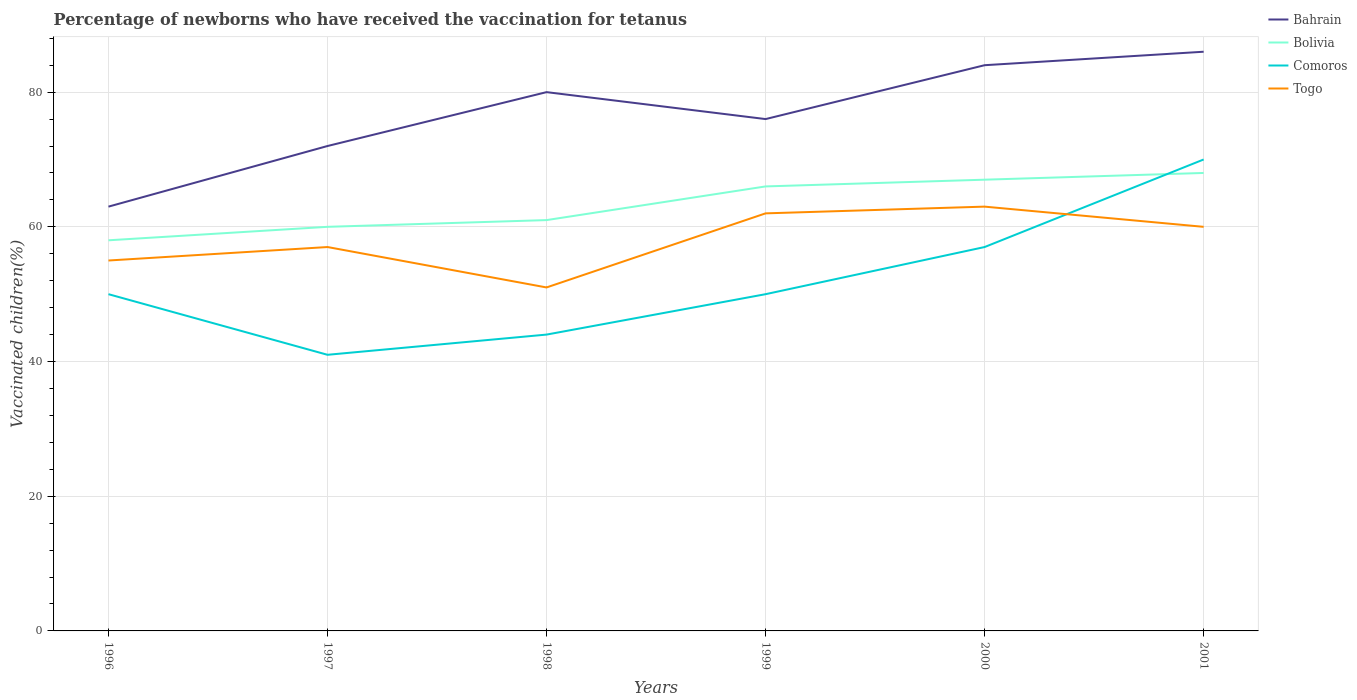How many different coloured lines are there?
Offer a terse response. 4. Does the line corresponding to Togo intersect with the line corresponding to Bahrain?
Your answer should be compact. No. Is the number of lines equal to the number of legend labels?
Give a very brief answer. Yes. Across all years, what is the maximum percentage of vaccinated children in Bolivia?
Provide a succinct answer. 58. What is the total percentage of vaccinated children in Bolivia in the graph?
Offer a terse response. -8. Is the percentage of vaccinated children in Togo strictly greater than the percentage of vaccinated children in Bahrain over the years?
Make the answer very short. Yes. What is the difference between two consecutive major ticks on the Y-axis?
Your answer should be very brief. 20. Are the values on the major ticks of Y-axis written in scientific E-notation?
Ensure brevity in your answer.  No. Does the graph contain any zero values?
Make the answer very short. No. Where does the legend appear in the graph?
Your answer should be very brief. Top right. How are the legend labels stacked?
Provide a succinct answer. Vertical. What is the title of the graph?
Offer a terse response. Percentage of newborns who have received the vaccination for tetanus. What is the label or title of the Y-axis?
Your response must be concise. Vaccinated children(%). What is the Vaccinated children(%) of Bahrain in 1996?
Make the answer very short. 63. What is the Vaccinated children(%) of Bolivia in 1996?
Your response must be concise. 58. What is the Vaccinated children(%) in Comoros in 1996?
Your answer should be compact. 50. What is the Vaccinated children(%) of Togo in 1996?
Keep it short and to the point. 55. What is the Vaccinated children(%) of Bolivia in 1997?
Provide a short and direct response. 60. What is the Vaccinated children(%) in Comoros in 1997?
Ensure brevity in your answer.  41. What is the Vaccinated children(%) in Togo in 1997?
Your answer should be very brief. 57. What is the Vaccinated children(%) in Comoros in 1998?
Your answer should be very brief. 44. What is the Vaccinated children(%) of Togo in 1998?
Offer a terse response. 51. What is the Vaccinated children(%) of Bahrain in 1999?
Give a very brief answer. 76. What is the Vaccinated children(%) in Bolivia in 1999?
Provide a succinct answer. 66. What is the Vaccinated children(%) of Bolivia in 2000?
Ensure brevity in your answer.  67. What is the Vaccinated children(%) of Comoros in 2000?
Give a very brief answer. 57. What is the Vaccinated children(%) of Togo in 2000?
Make the answer very short. 63. What is the Vaccinated children(%) of Bahrain in 2001?
Ensure brevity in your answer.  86. What is the Vaccinated children(%) of Bolivia in 2001?
Provide a succinct answer. 68. What is the Vaccinated children(%) in Comoros in 2001?
Provide a succinct answer. 70. What is the Vaccinated children(%) of Togo in 2001?
Offer a very short reply. 60. Across all years, what is the maximum Vaccinated children(%) of Bolivia?
Provide a succinct answer. 68. Across all years, what is the maximum Vaccinated children(%) in Comoros?
Give a very brief answer. 70. Across all years, what is the maximum Vaccinated children(%) in Togo?
Provide a short and direct response. 63. Across all years, what is the minimum Vaccinated children(%) in Bolivia?
Offer a very short reply. 58. Across all years, what is the minimum Vaccinated children(%) of Comoros?
Ensure brevity in your answer.  41. What is the total Vaccinated children(%) in Bahrain in the graph?
Offer a terse response. 461. What is the total Vaccinated children(%) of Bolivia in the graph?
Your answer should be compact. 380. What is the total Vaccinated children(%) in Comoros in the graph?
Your answer should be very brief. 312. What is the total Vaccinated children(%) in Togo in the graph?
Provide a short and direct response. 348. What is the difference between the Vaccinated children(%) of Bahrain in 1996 and that in 1997?
Your answer should be compact. -9. What is the difference between the Vaccinated children(%) in Bahrain in 1996 and that in 1998?
Offer a terse response. -17. What is the difference between the Vaccinated children(%) of Togo in 1996 and that in 1998?
Your answer should be compact. 4. What is the difference between the Vaccinated children(%) in Comoros in 1996 and that in 1999?
Give a very brief answer. 0. What is the difference between the Vaccinated children(%) of Bahrain in 1996 and that in 2000?
Your answer should be very brief. -21. What is the difference between the Vaccinated children(%) of Bolivia in 1996 and that in 2000?
Give a very brief answer. -9. What is the difference between the Vaccinated children(%) of Comoros in 1996 and that in 2000?
Provide a succinct answer. -7. What is the difference between the Vaccinated children(%) in Bahrain in 1996 and that in 2001?
Offer a very short reply. -23. What is the difference between the Vaccinated children(%) in Bolivia in 1996 and that in 2001?
Offer a terse response. -10. What is the difference between the Vaccinated children(%) of Comoros in 1996 and that in 2001?
Provide a short and direct response. -20. What is the difference between the Vaccinated children(%) of Togo in 1996 and that in 2001?
Make the answer very short. -5. What is the difference between the Vaccinated children(%) in Bolivia in 1997 and that in 1998?
Provide a short and direct response. -1. What is the difference between the Vaccinated children(%) in Comoros in 1997 and that in 1998?
Offer a terse response. -3. What is the difference between the Vaccinated children(%) of Bahrain in 1997 and that in 1999?
Your answer should be very brief. -4. What is the difference between the Vaccinated children(%) in Togo in 1997 and that in 1999?
Provide a short and direct response. -5. What is the difference between the Vaccinated children(%) in Bahrain in 1997 and that in 2000?
Your answer should be very brief. -12. What is the difference between the Vaccinated children(%) of Bolivia in 1997 and that in 2000?
Offer a terse response. -7. What is the difference between the Vaccinated children(%) of Togo in 1997 and that in 2000?
Give a very brief answer. -6. What is the difference between the Vaccinated children(%) in Bolivia in 1997 and that in 2001?
Offer a terse response. -8. What is the difference between the Vaccinated children(%) in Bolivia in 1998 and that in 1999?
Make the answer very short. -5. What is the difference between the Vaccinated children(%) in Bahrain in 1998 and that in 2001?
Ensure brevity in your answer.  -6. What is the difference between the Vaccinated children(%) in Bolivia in 1998 and that in 2001?
Provide a short and direct response. -7. What is the difference between the Vaccinated children(%) in Bahrain in 1999 and that in 2000?
Provide a short and direct response. -8. What is the difference between the Vaccinated children(%) of Bolivia in 1999 and that in 2000?
Give a very brief answer. -1. What is the difference between the Vaccinated children(%) in Togo in 1999 and that in 2000?
Provide a succinct answer. -1. What is the difference between the Vaccinated children(%) of Bahrain in 1999 and that in 2001?
Keep it short and to the point. -10. What is the difference between the Vaccinated children(%) in Bolivia in 1999 and that in 2001?
Offer a very short reply. -2. What is the difference between the Vaccinated children(%) of Togo in 1999 and that in 2001?
Provide a succinct answer. 2. What is the difference between the Vaccinated children(%) of Bolivia in 2000 and that in 2001?
Provide a short and direct response. -1. What is the difference between the Vaccinated children(%) in Bahrain in 1996 and the Vaccinated children(%) in Bolivia in 1997?
Give a very brief answer. 3. What is the difference between the Vaccinated children(%) of Bahrain in 1996 and the Vaccinated children(%) of Comoros in 1997?
Your answer should be very brief. 22. What is the difference between the Vaccinated children(%) in Bahrain in 1996 and the Vaccinated children(%) in Togo in 1997?
Give a very brief answer. 6. What is the difference between the Vaccinated children(%) in Bolivia in 1996 and the Vaccinated children(%) in Comoros in 1997?
Offer a very short reply. 17. What is the difference between the Vaccinated children(%) in Bolivia in 1996 and the Vaccinated children(%) in Togo in 1997?
Your answer should be very brief. 1. What is the difference between the Vaccinated children(%) in Comoros in 1996 and the Vaccinated children(%) in Togo in 1997?
Your response must be concise. -7. What is the difference between the Vaccinated children(%) of Bahrain in 1996 and the Vaccinated children(%) of Bolivia in 1998?
Provide a short and direct response. 2. What is the difference between the Vaccinated children(%) in Bahrain in 1996 and the Vaccinated children(%) in Comoros in 1998?
Provide a succinct answer. 19. What is the difference between the Vaccinated children(%) in Comoros in 1996 and the Vaccinated children(%) in Togo in 1998?
Make the answer very short. -1. What is the difference between the Vaccinated children(%) in Bahrain in 1996 and the Vaccinated children(%) in Bolivia in 1999?
Your answer should be compact. -3. What is the difference between the Vaccinated children(%) in Bahrain in 1996 and the Vaccinated children(%) in Comoros in 1999?
Your answer should be compact. 13. What is the difference between the Vaccinated children(%) in Bolivia in 1996 and the Vaccinated children(%) in Comoros in 1999?
Make the answer very short. 8. What is the difference between the Vaccinated children(%) in Bolivia in 1996 and the Vaccinated children(%) in Togo in 1999?
Make the answer very short. -4. What is the difference between the Vaccinated children(%) of Bahrain in 1996 and the Vaccinated children(%) of Bolivia in 2000?
Keep it short and to the point. -4. What is the difference between the Vaccinated children(%) in Bahrain in 1996 and the Vaccinated children(%) in Togo in 2000?
Ensure brevity in your answer.  0. What is the difference between the Vaccinated children(%) of Bolivia in 1996 and the Vaccinated children(%) of Comoros in 2000?
Your response must be concise. 1. What is the difference between the Vaccinated children(%) of Bolivia in 1996 and the Vaccinated children(%) of Togo in 2000?
Your response must be concise. -5. What is the difference between the Vaccinated children(%) in Comoros in 1996 and the Vaccinated children(%) in Togo in 2000?
Provide a short and direct response. -13. What is the difference between the Vaccinated children(%) of Bahrain in 1996 and the Vaccinated children(%) of Bolivia in 2001?
Your answer should be compact. -5. What is the difference between the Vaccinated children(%) in Bolivia in 1996 and the Vaccinated children(%) in Comoros in 2001?
Keep it short and to the point. -12. What is the difference between the Vaccinated children(%) of Comoros in 1996 and the Vaccinated children(%) of Togo in 2001?
Your answer should be very brief. -10. What is the difference between the Vaccinated children(%) of Bahrain in 1997 and the Vaccinated children(%) of Bolivia in 1998?
Make the answer very short. 11. What is the difference between the Vaccinated children(%) in Bolivia in 1997 and the Vaccinated children(%) in Togo in 1998?
Ensure brevity in your answer.  9. What is the difference between the Vaccinated children(%) in Bahrain in 1997 and the Vaccinated children(%) in Togo in 1999?
Offer a very short reply. 10. What is the difference between the Vaccinated children(%) in Bolivia in 1997 and the Vaccinated children(%) in Comoros in 1999?
Provide a succinct answer. 10. What is the difference between the Vaccinated children(%) of Bolivia in 1997 and the Vaccinated children(%) of Togo in 1999?
Provide a succinct answer. -2. What is the difference between the Vaccinated children(%) of Bahrain in 1997 and the Vaccinated children(%) of Comoros in 2000?
Your answer should be compact. 15. What is the difference between the Vaccinated children(%) in Bolivia in 1997 and the Vaccinated children(%) in Comoros in 2000?
Keep it short and to the point. 3. What is the difference between the Vaccinated children(%) in Bahrain in 1997 and the Vaccinated children(%) in Bolivia in 2001?
Your response must be concise. 4. What is the difference between the Vaccinated children(%) of Bahrain in 1997 and the Vaccinated children(%) of Togo in 2001?
Make the answer very short. 12. What is the difference between the Vaccinated children(%) of Bolivia in 1997 and the Vaccinated children(%) of Comoros in 2001?
Ensure brevity in your answer.  -10. What is the difference between the Vaccinated children(%) in Comoros in 1997 and the Vaccinated children(%) in Togo in 2001?
Offer a very short reply. -19. What is the difference between the Vaccinated children(%) in Bahrain in 1998 and the Vaccinated children(%) in Comoros in 1999?
Keep it short and to the point. 30. What is the difference between the Vaccinated children(%) of Bolivia in 1998 and the Vaccinated children(%) of Comoros in 1999?
Offer a very short reply. 11. What is the difference between the Vaccinated children(%) of Bolivia in 1998 and the Vaccinated children(%) of Togo in 1999?
Your answer should be very brief. -1. What is the difference between the Vaccinated children(%) of Bahrain in 1998 and the Vaccinated children(%) of Bolivia in 2000?
Keep it short and to the point. 13. What is the difference between the Vaccinated children(%) in Bahrain in 1998 and the Vaccinated children(%) in Comoros in 2000?
Your answer should be compact. 23. What is the difference between the Vaccinated children(%) in Bahrain in 1998 and the Vaccinated children(%) in Togo in 2000?
Make the answer very short. 17. What is the difference between the Vaccinated children(%) in Bahrain in 1998 and the Vaccinated children(%) in Comoros in 2001?
Make the answer very short. 10. What is the difference between the Vaccinated children(%) in Bahrain in 1998 and the Vaccinated children(%) in Togo in 2001?
Provide a short and direct response. 20. What is the difference between the Vaccinated children(%) of Bolivia in 1998 and the Vaccinated children(%) of Togo in 2001?
Keep it short and to the point. 1. What is the difference between the Vaccinated children(%) of Comoros in 1998 and the Vaccinated children(%) of Togo in 2001?
Give a very brief answer. -16. What is the difference between the Vaccinated children(%) in Bahrain in 1999 and the Vaccinated children(%) in Bolivia in 2000?
Your answer should be very brief. 9. What is the difference between the Vaccinated children(%) of Bahrain in 1999 and the Vaccinated children(%) of Togo in 2000?
Keep it short and to the point. 13. What is the difference between the Vaccinated children(%) in Comoros in 1999 and the Vaccinated children(%) in Togo in 2000?
Keep it short and to the point. -13. What is the difference between the Vaccinated children(%) of Bahrain in 1999 and the Vaccinated children(%) of Bolivia in 2001?
Your response must be concise. 8. What is the difference between the Vaccinated children(%) of Bahrain in 1999 and the Vaccinated children(%) of Togo in 2001?
Offer a terse response. 16. What is the difference between the Vaccinated children(%) of Comoros in 1999 and the Vaccinated children(%) of Togo in 2001?
Provide a succinct answer. -10. What is the difference between the Vaccinated children(%) in Bahrain in 2000 and the Vaccinated children(%) in Bolivia in 2001?
Provide a succinct answer. 16. What is the difference between the Vaccinated children(%) in Bolivia in 2000 and the Vaccinated children(%) in Togo in 2001?
Your response must be concise. 7. What is the difference between the Vaccinated children(%) of Comoros in 2000 and the Vaccinated children(%) of Togo in 2001?
Give a very brief answer. -3. What is the average Vaccinated children(%) of Bahrain per year?
Give a very brief answer. 76.83. What is the average Vaccinated children(%) of Bolivia per year?
Offer a very short reply. 63.33. What is the average Vaccinated children(%) in Comoros per year?
Provide a short and direct response. 52. What is the average Vaccinated children(%) of Togo per year?
Your answer should be compact. 58. In the year 1996, what is the difference between the Vaccinated children(%) in Bahrain and Vaccinated children(%) in Bolivia?
Your answer should be very brief. 5. In the year 1996, what is the difference between the Vaccinated children(%) in Bolivia and Vaccinated children(%) in Comoros?
Offer a terse response. 8. In the year 1996, what is the difference between the Vaccinated children(%) of Comoros and Vaccinated children(%) of Togo?
Offer a very short reply. -5. In the year 1997, what is the difference between the Vaccinated children(%) of Bahrain and Vaccinated children(%) of Bolivia?
Give a very brief answer. 12. In the year 1997, what is the difference between the Vaccinated children(%) of Bahrain and Vaccinated children(%) of Comoros?
Offer a very short reply. 31. In the year 1997, what is the difference between the Vaccinated children(%) in Bahrain and Vaccinated children(%) in Togo?
Provide a short and direct response. 15. In the year 1997, what is the difference between the Vaccinated children(%) of Bolivia and Vaccinated children(%) of Comoros?
Provide a short and direct response. 19. In the year 1997, what is the difference between the Vaccinated children(%) in Bolivia and Vaccinated children(%) in Togo?
Provide a short and direct response. 3. In the year 1997, what is the difference between the Vaccinated children(%) in Comoros and Vaccinated children(%) in Togo?
Offer a very short reply. -16. In the year 1998, what is the difference between the Vaccinated children(%) of Bahrain and Vaccinated children(%) of Bolivia?
Your answer should be very brief. 19. In the year 1998, what is the difference between the Vaccinated children(%) in Bahrain and Vaccinated children(%) in Comoros?
Your response must be concise. 36. In the year 1998, what is the difference between the Vaccinated children(%) of Bolivia and Vaccinated children(%) of Togo?
Give a very brief answer. 10. In the year 1999, what is the difference between the Vaccinated children(%) in Bahrain and Vaccinated children(%) in Bolivia?
Offer a terse response. 10. In the year 1999, what is the difference between the Vaccinated children(%) of Comoros and Vaccinated children(%) of Togo?
Your answer should be very brief. -12. In the year 2000, what is the difference between the Vaccinated children(%) in Bolivia and Vaccinated children(%) in Togo?
Give a very brief answer. 4. In the year 2001, what is the difference between the Vaccinated children(%) of Bahrain and Vaccinated children(%) of Togo?
Your response must be concise. 26. In the year 2001, what is the difference between the Vaccinated children(%) in Bolivia and Vaccinated children(%) in Comoros?
Ensure brevity in your answer.  -2. In the year 2001, what is the difference between the Vaccinated children(%) in Comoros and Vaccinated children(%) in Togo?
Keep it short and to the point. 10. What is the ratio of the Vaccinated children(%) of Bahrain in 1996 to that in 1997?
Make the answer very short. 0.88. What is the ratio of the Vaccinated children(%) of Bolivia in 1996 to that in 1997?
Make the answer very short. 0.97. What is the ratio of the Vaccinated children(%) of Comoros in 1996 to that in 1997?
Your answer should be compact. 1.22. What is the ratio of the Vaccinated children(%) of Togo in 1996 to that in 1997?
Keep it short and to the point. 0.96. What is the ratio of the Vaccinated children(%) of Bahrain in 1996 to that in 1998?
Ensure brevity in your answer.  0.79. What is the ratio of the Vaccinated children(%) in Bolivia in 1996 to that in 1998?
Make the answer very short. 0.95. What is the ratio of the Vaccinated children(%) of Comoros in 1996 to that in 1998?
Ensure brevity in your answer.  1.14. What is the ratio of the Vaccinated children(%) in Togo in 1996 to that in 1998?
Your answer should be compact. 1.08. What is the ratio of the Vaccinated children(%) of Bahrain in 1996 to that in 1999?
Offer a terse response. 0.83. What is the ratio of the Vaccinated children(%) of Bolivia in 1996 to that in 1999?
Keep it short and to the point. 0.88. What is the ratio of the Vaccinated children(%) in Togo in 1996 to that in 1999?
Offer a terse response. 0.89. What is the ratio of the Vaccinated children(%) in Bolivia in 1996 to that in 2000?
Offer a terse response. 0.87. What is the ratio of the Vaccinated children(%) of Comoros in 1996 to that in 2000?
Provide a short and direct response. 0.88. What is the ratio of the Vaccinated children(%) of Togo in 1996 to that in 2000?
Your answer should be compact. 0.87. What is the ratio of the Vaccinated children(%) of Bahrain in 1996 to that in 2001?
Offer a very short reply. 0.73. What is the ratio of the Vaccinated children(%) in Bolivia in 1996 to that in 2001?
Ensure brevity in your answer.  0.85. What is the ratio of the Vaccinated children(%) in Comoros in 1996 to that in 2001?
Your answer should be compact. 0.71. What is the ratio of the Vaccinated children(%) of Bolivia in 1997 to that in 1998?
Offer a very short reply. 0.98. What is the ratio of the Vaccinated children(%) in Comoros in 1997 to that in 1998?
Offer a terse response. 0.93. What is the ratio of the Vaccinated children(%) of Togo in 1997 to that in 1998?
Your response must be concise. 1.12. What is the ratio of the Vaccinated children(%) in Bahrain in 1997 to that in 1999?
Provide a succinct answer. 0.95. What is the ratio of the Vaccinated children(%) of Comoros in 1997 to that in 1999?
Provide a succinct answer. 0.82. What is the ratio of the Vaccinated children(%) in Togo in 1997 to that in 1999?
Ensure brevity in your answer.  0.92. What is the ratio of the Vaccinated children(%) in Bahrain in 1997 to that in 2000?
Give a very brief answer. 0.86. What is the ratio of the Vaccinated children(%) of Bolivia in 1997 to that in 2000?
Provide a succinct answer. 0.9. What is the ratio of the Vaccinated children(%) of Comoros in 1997 to that in 2000?
Your answer should be compact. 0.72. What is the ratio of the Vaccinated children(%) of Togo in 1997 to that in 2000?
Provide a short and direct response. 0.9. What is the ratio of the Vaccinated children(%) of Bahrain in 1997 to that in 2001?
Offer a very short reply. 0.84. What is the ratio of the Vaccinated children(%) of Bolivia in 1997 to that in 2001?
Provide a short and direct response. 0.88. What is the ratio of the Vaccinated children(%) of Comoros in 1997 to that in 2001?
Your answer should be compact. 0.59. What is the ratio of the Vaccinated children(%) in Bahrain in 1998 to that in 1999?
Make the answer very short. 1.05. What is the ratio of the Vaccinated children(%) of Bolivia in 1998 to that in 1999?
Provide a short and direct response. 0.92. What is the ratio of the Vaccinated children(%) of Togo in 1998 to that in 1999?
Your answer should be compact. 0.82. What is the ratio of the Vaccinated children(%) in Bolivia in 1998 to that in 2000?
Provide a short and direct response. 0.91. What is the ratio of the Vaccinated children(%) of Comoros in 1998 to that in 2000?
Your answer should be very brief. 0.77. What is the ratio of the Vaccinated children(%) in Togo in 1998 to that in 2000?
Ensure brevity in your answer.  0.81. What is the ratio of the Vaccinated children(%) of Bahrain in 1998 to that in 2001?
Keep it short and to the point. 0.93. What is the ratio of the Vaccinated children(%) in Bolivia in 1998 to that in 2001?
Keep it short and to the point. 0.9. What is the ratio of the Vaccinated children(%) in Comoros in 1998 to that in 2001?
Provide a short and direct response. 0.63. What is the ratio of the Vaccinated children(%) in Bahrain in 1999 to that in 2000?
Give a very brief answer. 0.9. What is the ratio of the Vaccinated children(%) in Bolivia in 1999 to that in 2000?
Provide a succinct answer. 0.99. What is the ratio of the Vaccinated children(%) of Comoros in 1999 to that in 2000?
Your answer should be very brief. 0.88. What is the ratio of the Vaccinated children(%) in Togo in 1999 to that in 2000?
Your response must be concise. 0.98. What is the ratio of the Vaccinated children(%) of Bahrain in 1999 to that in 2001?
Make the answer very short. 0.88. What is the ratio of the Vaccinated children(%) in Bolivia in 1999 to that in 2001?
Provide a succinct answer. 0.97. What is the ratio of the Vaccinated children(%) of Comoros in 1999 to that in 2001?
Ensure brevity in your answer.  0.71. What is the ratio of the Vaccinated children(%) of Togo in 1999 to that in 2001?
Ensure brevity in your answer.  1.03. What is the ratio of the Vaccinated children(%) of Bahrain in 2000 to that in 2001?
Offer a very short reply. 0.98. What is the ratio of the Vaccinated children(%) in Comoros in 2000 to that in 2001?
Offer a terse response. 0.81. What is the difference between the highest and the second highest Vaccinated children(%) of Bahrain?
Your response must be concise. 2. What is the difference between the highest and the lowest Vaccinated children(%) of Bahrain?
Offer a terse response. 23. What is the difference between the highest and the lowest Vaccinated children(%) of Comoros?
Offer a terse response. 29. 